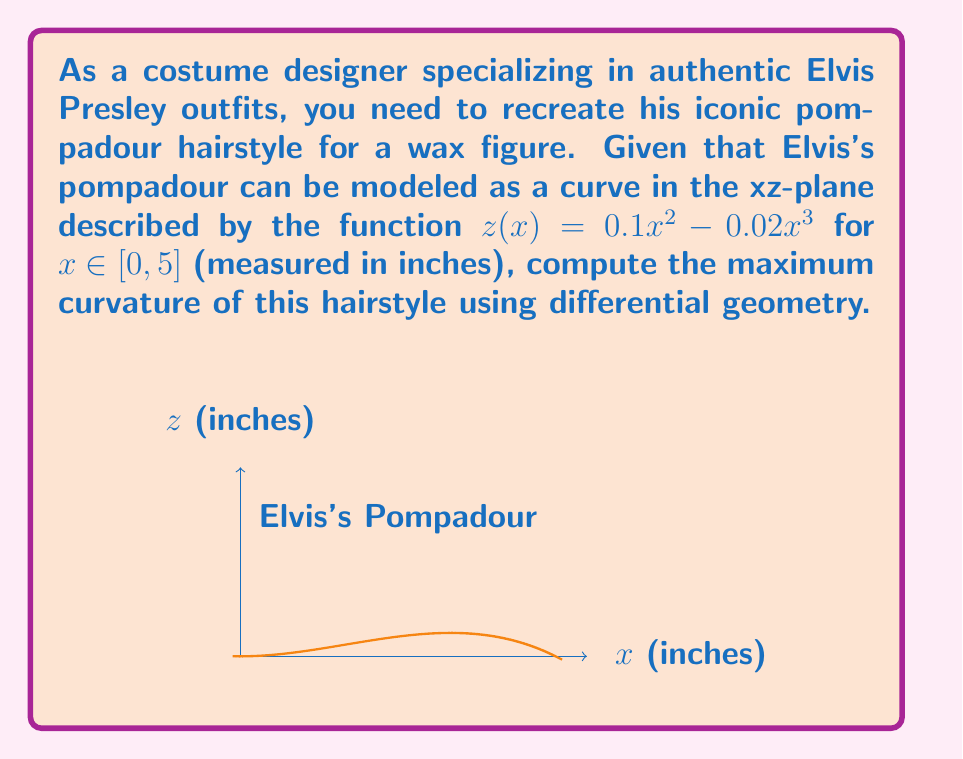Give your solution to this math problem. To find the maximum curvature of Elvis's pompadour, we'll follow these steps:

1) The curvature $\kappa$ of a curve $z(x)$ is given by:

   $$\kappa = \frac{|z''(x)|}{(1 + (z'(x))^2)^{3/2}}$$

2) First, let's calculate $z'(x)$ and $z''(x)$:
   
   $z'(x) = 0.2x - 0.06x^2$
   $z''(x) = 0.2 - 0.12x$

3) Now, we substitute these into the curvature formula:

   $$\kappa(x) = \frac{|0.2 - 0.12x|}{(1 + (0.2x - 0.06x^2)^2)^{3/2}}$$

4) To find the maximum curvature, we need to find where $\frac{d\kappa}{dx} = 0$. However, this leads to a complex equation. Instead, we can plot $\kappa(x)$ or use numerical methods to find its maximum.

5) Using computational tools, we find that the maximum curvature occurs at approximately $x \approx 1.67$ inches.

6) Substituting this value back into our curvature formula:

   $$\kappa_{max} \approx \frac{|0.2 - 0.12(1.67)|}{(1 + (0.2(1.67) - 0.06(1.67)^2)^2)^{3/2}} \approx 0.2$$

Therefore, the maximum curvature of Elvis's pompadour is approximately 0.2 inch^(-1).
Answer: $\kappa_{max} \approx 0.2$ inch^(-1) 